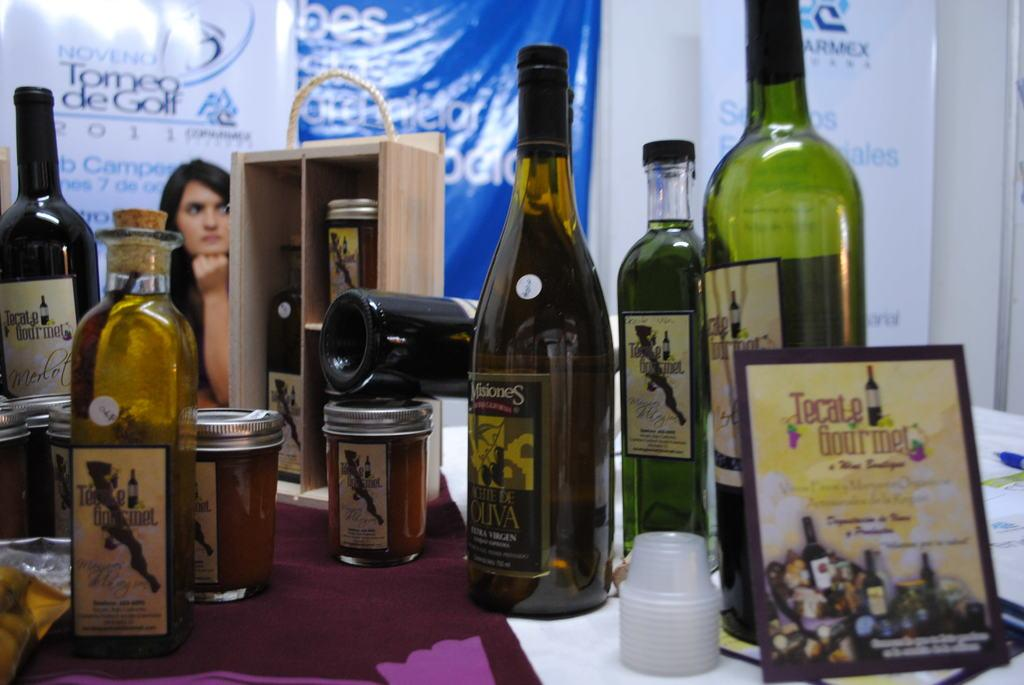<image>
Provide a brief description of the given image. A sign for Tecate Gourmet leans against a bottle. 